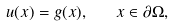<formula> <loc_0><loc_0><loc_500><loc_500>u ( x ) = g ( x ) , \quad x \in \partial \Omega ,</formula> 